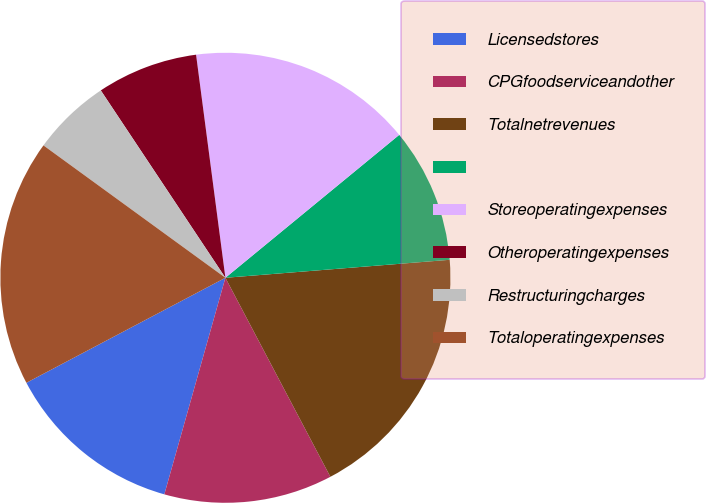Convert chart. <chart><loc_0><loc_0><loc_500><loc_500><pie_chart><fcel>Licensedstores<fcel>CPGfoodserviceandother<fcel>Totalnetrevenues<fcel>Unnamed: 3<fcel>Storeoperatingexpenses<fcel>Otheroperatingexpenses<fcel>Restructuringcharges<fcel>Totaloperatingexpenses<nl><fcel>12.9%<fcel>12.1%<fcel>18.55%<fcel>9.68%<fcel>16.13%<fcel>7.26%<fcel>5.65%<fcel>17.74%<nl></chart> 